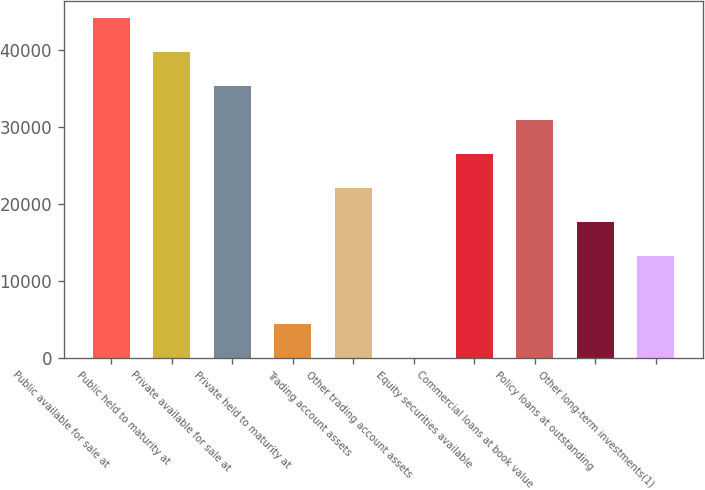Convert chart. <chart><loc_0><loc_0><loc_500><loc_500><bar_chart><fcel>Public available for sale at<fcel>Public held to maturity at<fcel>Private available for sale at<fcel>Private held to maturity at<fcel>Trading account assets<fcel>Other trading account assets<fcel>Equity securities available<fcel>Commercial loans at book value<fcel>Policy loans at outstanding<fcel>Other long-term investments(1)<nl><fcel>44222<fcel>39802.4<fcel>35382.8<fcel>4445.6<fcel>22124<fcel>26<fcel>26543.6<fcel>30963.2<fcel>17704.4<fcel>13284.8<nl></chart> 